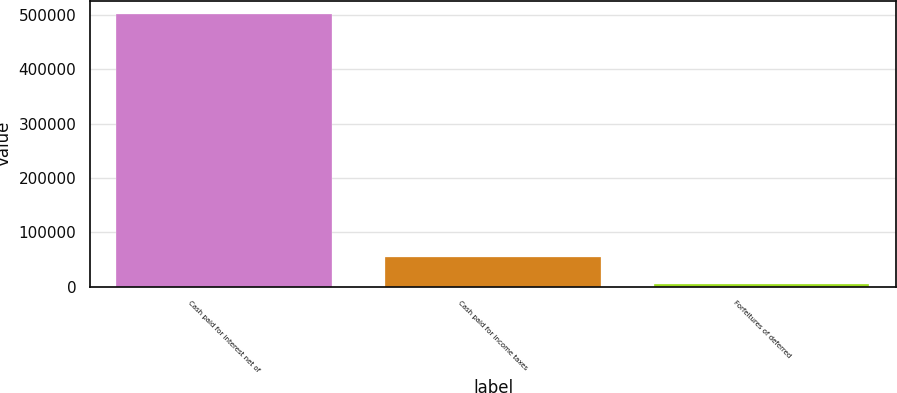Convert chart. <chart><loc_0><loc_0><loc_500><loc_500><bar_chart><fcel>Cash paid for interest net of<fcel>Cash paid for income taxes<fcel>Forfeitures of deferred<nl><fcel>500879<fcel>55055.9<fcel>5520<nl></chart> 